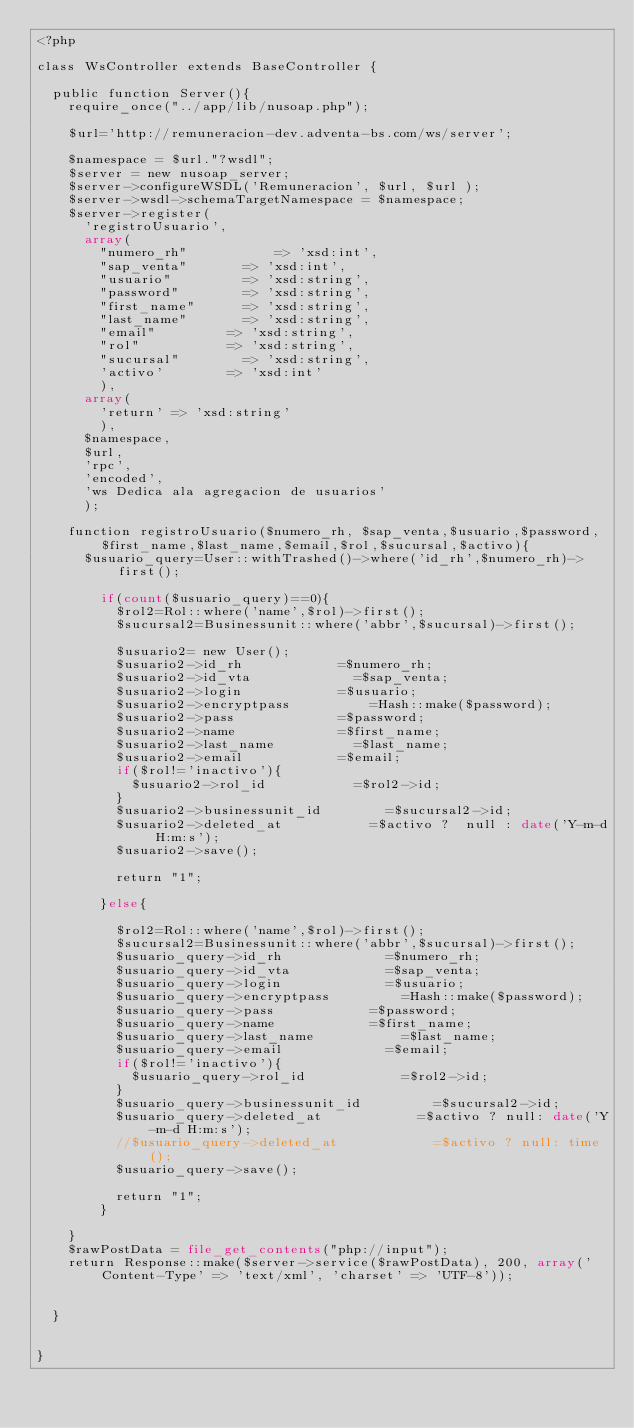Convert code to text. <code><loc_0><loc_0><loc_500><loc_500><_PHP_><?php

class WsController extends BaseController {

	public function Server(){
		require_once("../app/lib/nusoap.php");

		$url='http://remuneracion-dev.adventa-bs.com/ws/server';

		$namespace = $url."?wsdl";
		$server = new nusoap_server;
		$server->configureWSDL('Remuneracion', $url, $url );
		$server->wsdl->schemaTargetNamespace = $namespace;
		$server->register(
			'registroUsuario',
			array(
				"numero_rh"       		=> 'xsd:int',
				"sap_venta" 			=> 'xsd:int',
				"usuario" 				=> 'xsd:string',
				"password" 				=> 'xsd:string',
				"first_name" 			=> 'xsd:string',
				"last_name" 			=> 'xsd:string',
				"email" 				=> 'xsd:string',
				"rol" 					=> 'xsd:string',
				"sucursal" 				=> 'xsd:string',
				'activo'				=> 'xsd:int'
				),
			array(
				'return' => 'xsd:string'
				),
			$namespace,
			$url,
			'rpc',
			'encoded',
			'ws Dedica ala agregacion de usuarios'
			);

		function registroUsuario($numero_rh, $sap_venta,$usuario,$password,$first_name,$last_name,$email,$rol,$sucursal,$activo){
			$usuario_query=User::withTrashed()->where('id_rh',$numero_rh)->first();

				if(count($usuario_query)==0){
					$rol2=Rol::where('name',$rol)->first();
					$sucursal2=Businessunit::where('abbr',$sucursal)->first();

					$usuario2= new User();
					$usuario2->id_rh 						=$numero_rh;
					$usuario2->id_vta 						=$sap_venta;
					$usuario2->login 						=$usuario;
					$usuario2->encryptpass 					=Hash::make($password);
					$usuario2->pass 						=$password;
					$usuario2->name 						=$first_name;
					$usuario2->last_name 					=$last_name;
					$usuario2->email 						=$email;
					if($rol!='inactivo'){
						$usuario2->rol_id 					=$rol2->id;	
					}
					$usuario2->businessunit_id 				=$sucursal2->id;
					$usuario2->deleted_at 					=$activo ?  null : date('Y-m-d H:m:s');
					$usuario2->save(); 
					
					return "1";
					
				}else{

					$rol2=Rol::where('name',$rol)->first();
					$sucursal2=Businessunit::where('abbr',$sucursal)->first();
					$usuario_query->id_rh 						=$numero_rh;
					$usuario_query->id_vta 						=$sap_venta;
					$usuario_query->login 						=$usuario;
					$usuario_query->encryptpass 				=Hash::make($password);
					$usuario_query->pass 						=$password;
					$usuario_query->name 						=$first_name;
					$usuario_query->last_name 					=$last_name;
					$usuario_query->email 						=$email;
					if($rol!='inactivo'){
						$usuario_query->rol_id 						=$rol2->id;
					}
					$usuario_query->businessunit_id 				=$sucursal2->id;
					$usuario_query->deleted_at 						=$activo ? null: date('Y-m-d H:m:s');
					//$usuario_query->deleted_at 						=$activo ? null: time();
					$usuario_query->save();

					return "1";
				}

		}
		$rawPostData = file_get_contents("php://input");
		return Response::make($server->service($rawPostData), 200, array('Content-Type' => 'text/xml', 'charset' => 'UTF-8'));


	}


}</code> 